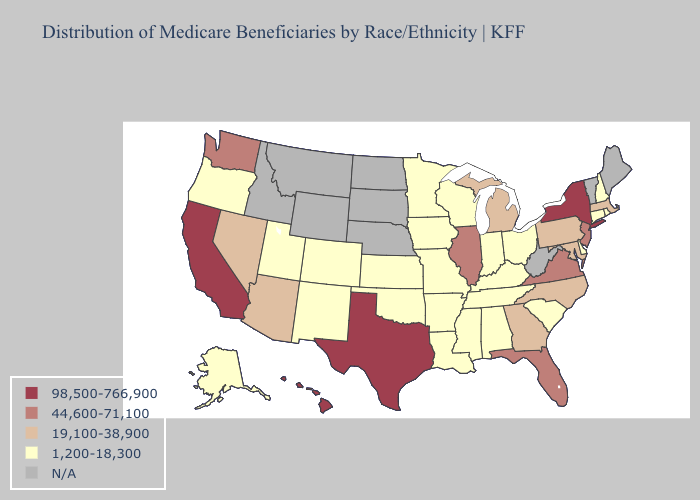Among the states that border Kentucky , does Missouri have the highest value?
Be succinct. No. Name the states that have a value in the range 44,600-71,100?
Answer briefly. Florida, Illinois, New Jersey, Virginia, Washington. What is the highest value in the West ?
Be succinct. 98,500-766,900. What is the value of New Mexico?
Write a very short answer. 1,200-18,300. Is the legend a continuous bar?
Be succinct. No. Name the states that have a value in the range 1,200-18,300?
Short answer required. Alabama, Alaska, Arkansas, Colorado, Connecticut, Delaware, Indiana, Iowa, Kansas, Kentucky, Louisiana, Minnesota, Mississippi, Missouri, New Hampshire, New Mexico, Ohio, Oklahoma, Oregon, Rhode Island, South Carolina, Tennessee, Utah, Wisconsin. What is the value of North Carolina?
Write a very short answer. 19,100-38,900. What is the value of Georgia?
Short answer required. 19,100-38,900. Name the states that have a value in the range N/A?
Give a very brief answer. Idaho, Maine, Montana, Nebraska, North Dakota, South Dakota, Vermont, West Virginia, Wyoming. Does the map have missing data?
Concise answer only. Yes. What is the highest value in the USA?
Be succinct. 98,500-766,900. Name the states that have a value in the range N/A?
Keep it brief. Idaho, Maine, Montana, Nebraska, North Dakota, South Dakota, Vermont, West Virginia, Wyoming. How many symbols are there in the legend?
Answer briefly. 5. How many symbols are there in the legend?
Keep it brief. 5. 